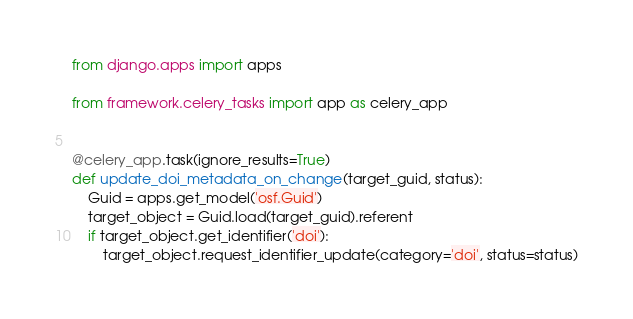<code> <loc_0><loc_0><loc_500><loc_500><_Python_>from django.apps import apps

from framework.celery_tasks import app as celery_app


@celery_app.task(ignore_results=True)
def update_doi_metadata_on_change(target_guid, status):
    Guid = apps.get_model('osf.Guid')
    target_object = Guid.load(target_guid).referent
    if target_object.get_identifier('doi'):
        target_object.request_identifier_update(category='doi', status=status)
</code> 